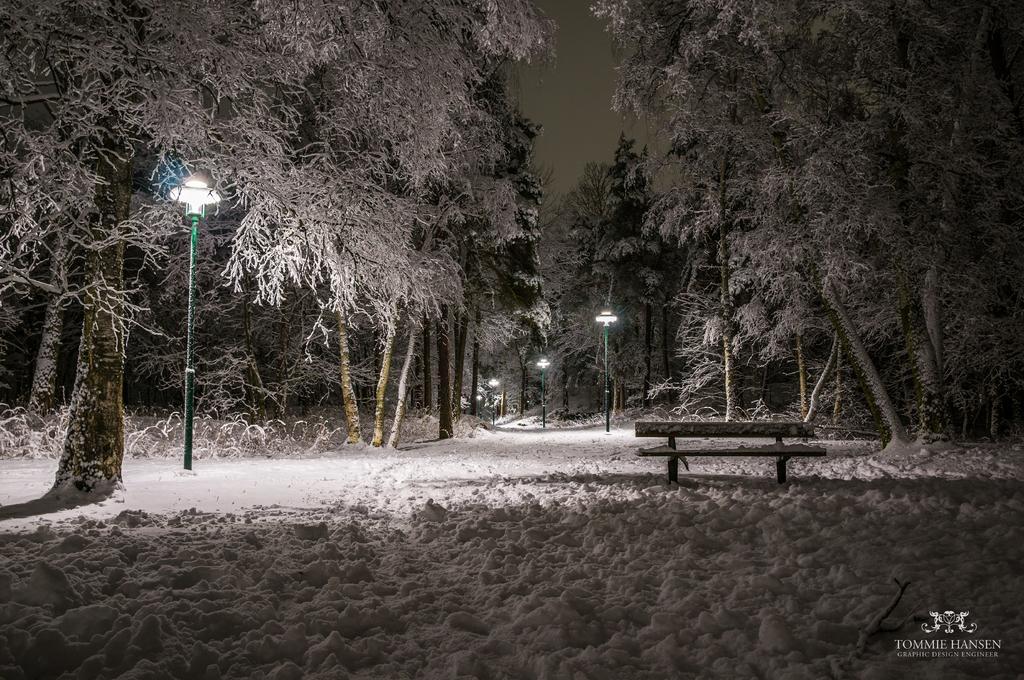Could you give a brief overview of what you see in this image? In this image there is a bench on the land covered with snow. There are few street lights. Behind there are few trees which are covered with snow. 